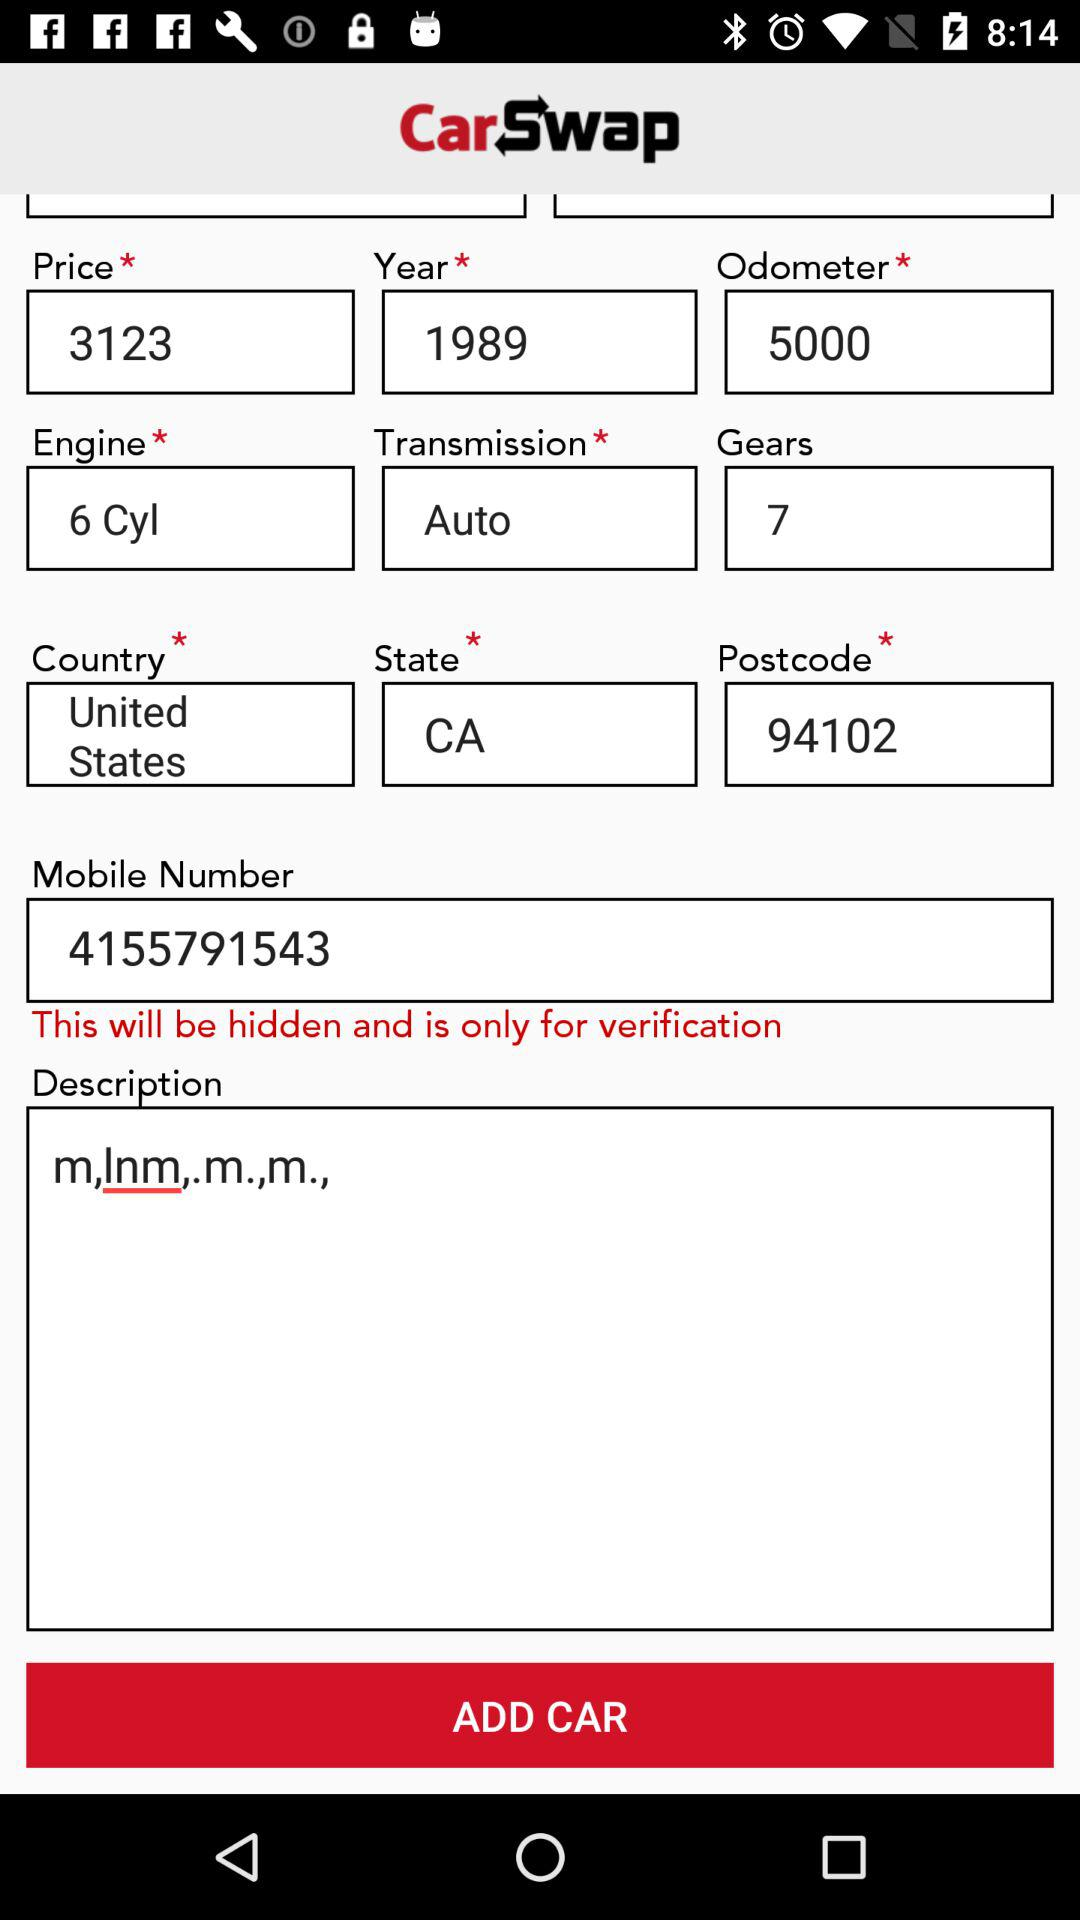From what state does the user belong? The user belongs to the CA state. 